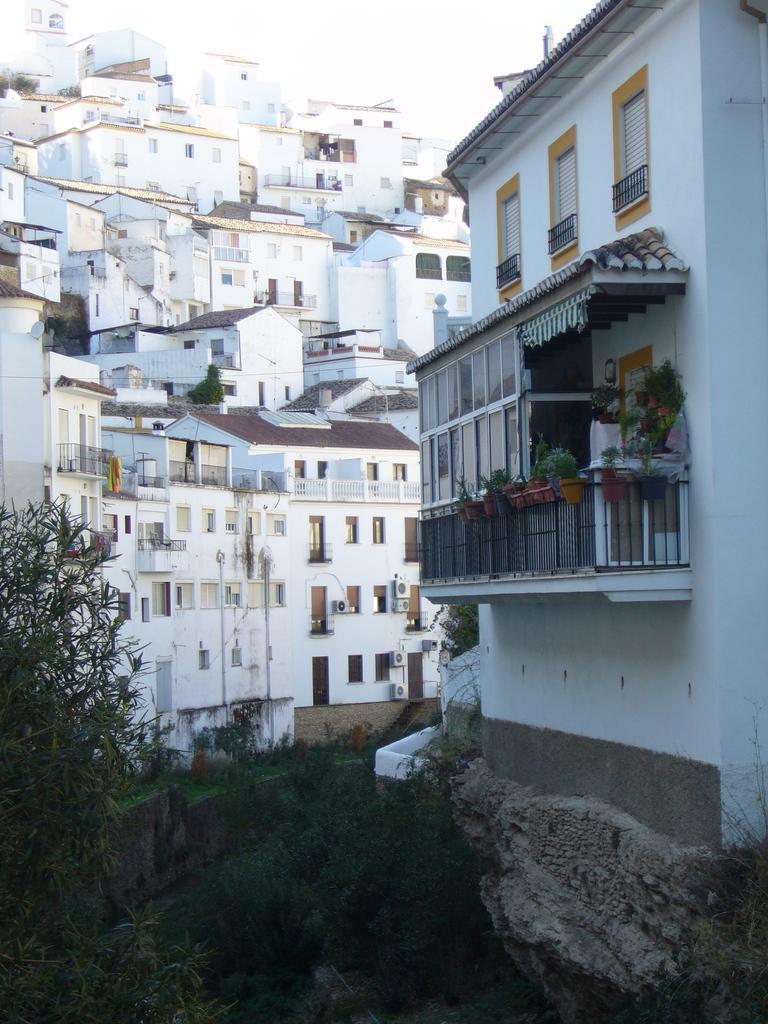How would you summarize this image in a sentence or two? In this image, there are some buildings they colored white. There are branches in the bottom left of the image. There is a sky at the top of the image. 